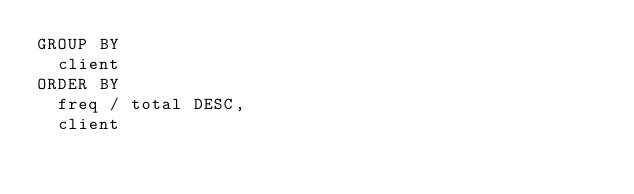<code> <loc_0><loc_0><loc_500><loc_500><_SQL_>GROUP BY
  client
ORDER BY
  freq / total DESC,
  client
</code> 